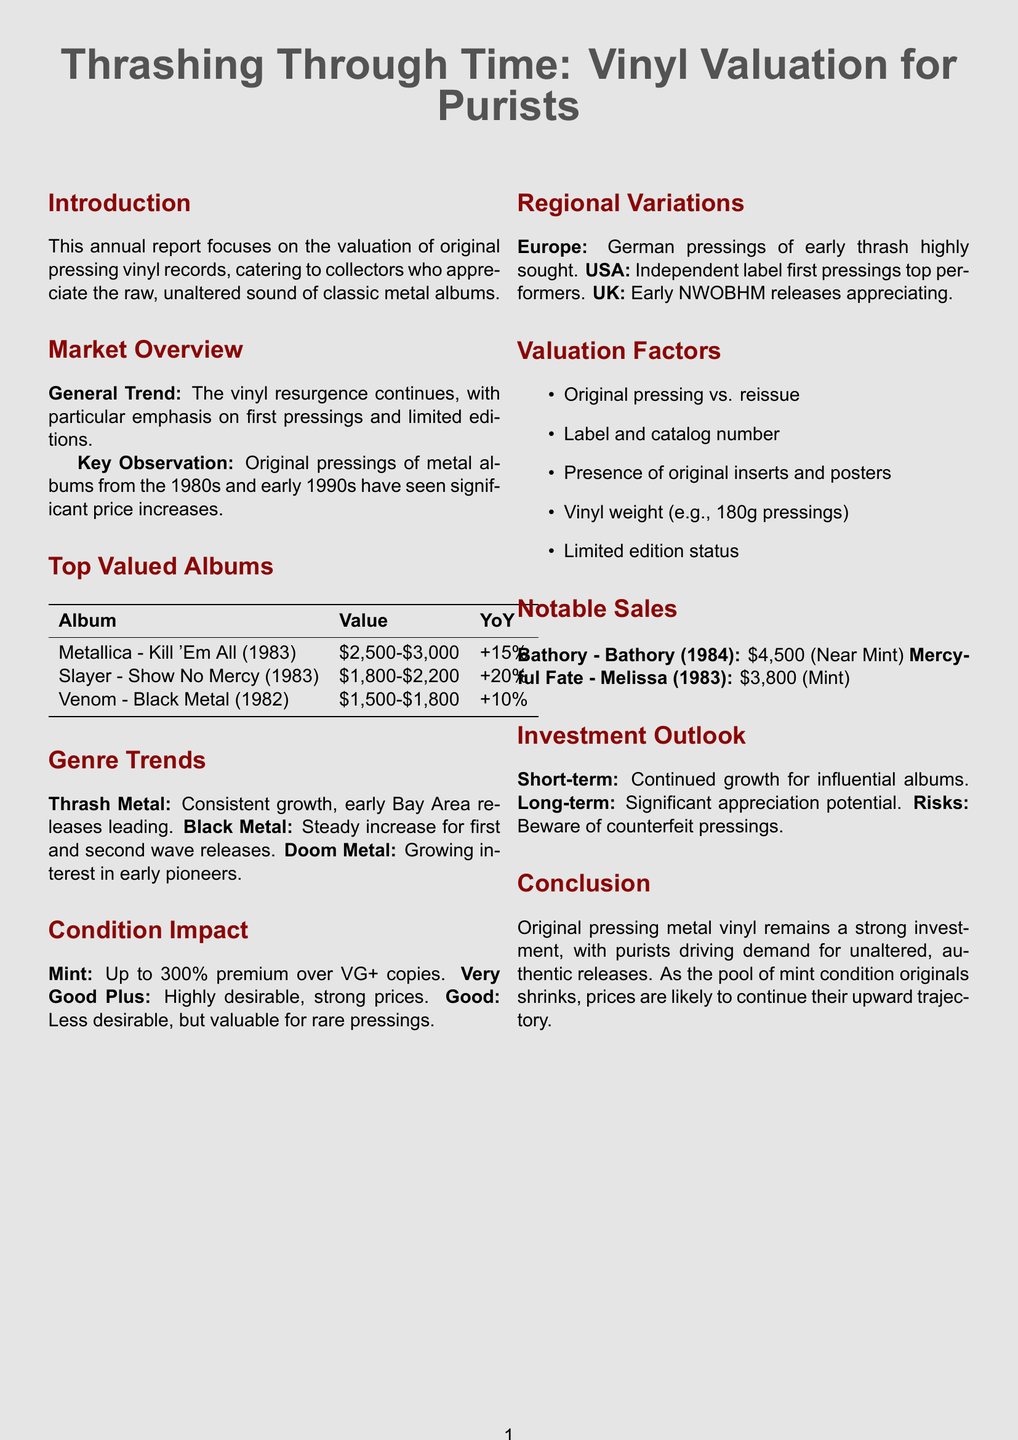what is the title of the report? The title of the report is stated at the beginning of the document.
Answer: Thrashing Through Time: Vinyl Valuation for Purists which album is valued between $1,800 and $2,200? The document lists the current values of top valued albums, including their price ranges.
Answer: Slayer - Show No Mercy what is the year of the Metallica album listed? The year of the Metallica album “Kill 'Em All” is provided in the top valued albums section.
Answer: 1983 what is the year-over-year change for Venom's "Black Metal"? The document includes the year-over-year change for each top valued album.
Answer: +10% which genre is experiencing consistent growth according to the trends? The genre-specific trends section highlights which genres are growing in value.
Answer: Thrash Metal what premium can near-mint condition original pressings command? The document details the premiums associated with the condition of vinyl records.
Answer: up to 300% what are two factors affecting valuation? The factors influencing the valuation of vinyl records are listed in the valuation factors section.
Answer: Original pressing vs. reissue, Label and catalog number what is the estimated value range of Metallica's "Kill 'Em All"? The current value is indicated in the top valued albums section.
Answer: $2,500 - $3,000 what was the sale price of the Mercyful Fate album? The document provides notable sales data including sale prices of specific albums.
Answer: $3,800 